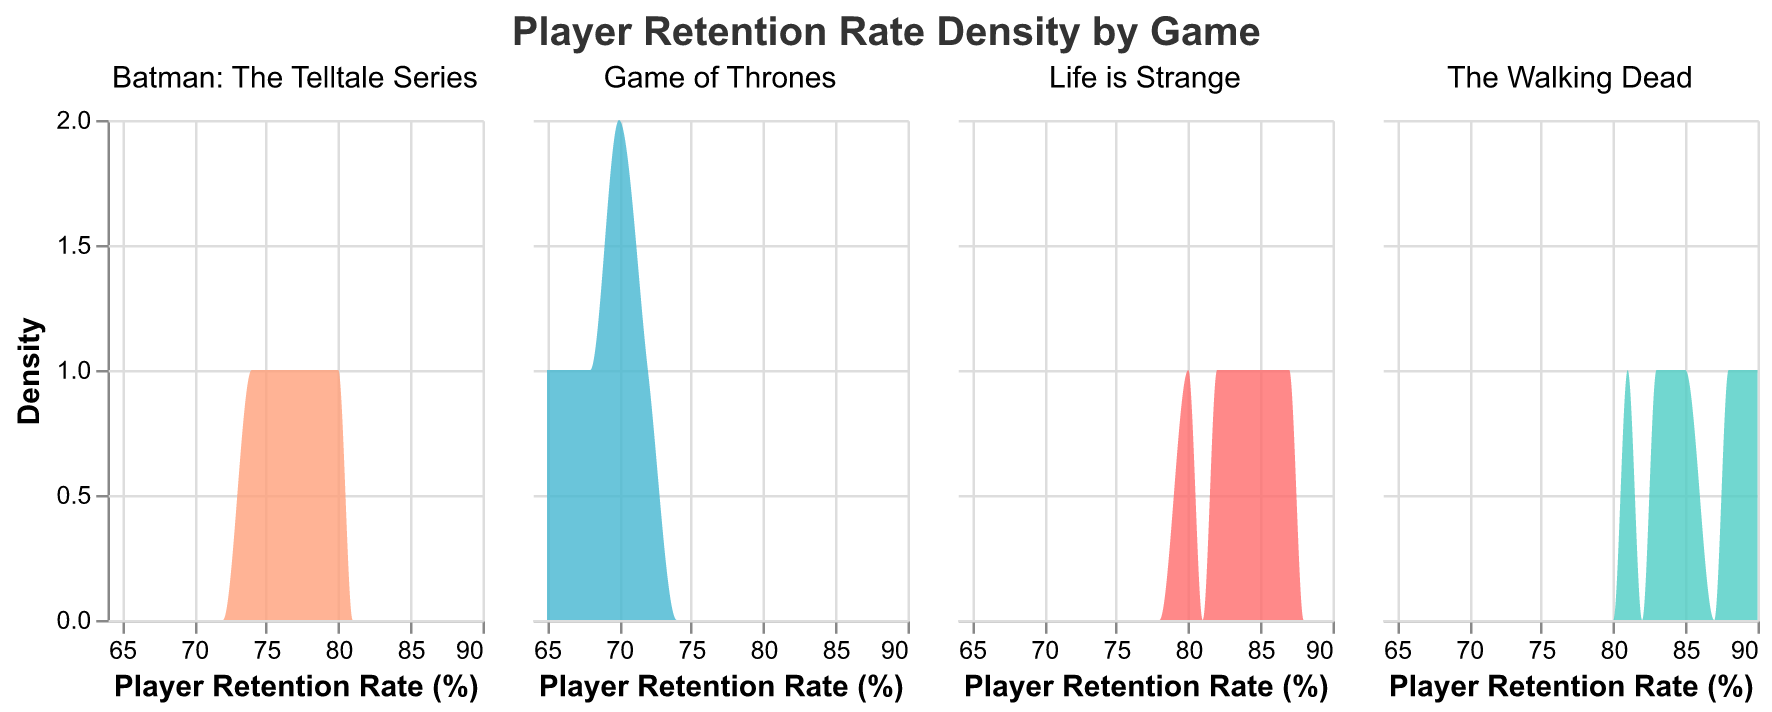What is the title of the figure? The title of the figure is typically displayed at the top of the plot. In this case, it is: "Player Retention Rate Density by Game"
Answer: Player Retention Rate Density by Game How is the x-axis labeled? The x-axis label is displayed at the bottom of the plot. Here, it is labeled: "Player Retention Rate (%)"
Answer: Player Retention Rate (%) Which game has the highest density peak? The game with the highest density peak can be identified by examining the peaks of each facet in the plot. The Walking Dead has the highest peak in the density plot.
Answer: The Walking Dead Which game has the widest spread of player retention rates? The game with the widest spread will have a wider range along the x-axis. Game of Thrones shows a wider spread of player retention rates compared to the others.
Answer: Game of Thrones Comparing "Life is Strange" and "Batman: The Telltale Series", which game has a higher player retention rate density at approximately 80%? By comparing the density areas around the 80% mark for both games in their respective plots, we can see that "Life is Strange" has a higher density at approximately 80%.
Answer: Life is Strange What is the color used to represent "The Walking Dead"? The color coding for "The Walking Dead" is seen in the plot and legend. It is represented by a teal-like color.
Answer: Teal What player retention rate does "Game of Thrones" have the highest density for? By examining the peak of the density plot for "Game of Thrones", the highest density occurs around the 70% player retention rate.
Answer: 70% Which game shows a consistent player retention rate across episodes, based on the density plot? A consistent player retention rate appears as a narrow, tall peak in the density plot. "The Walking Dead" seems to show a consistent player retention rate, particularly around high retention rates.
Answer: The Walking Dead Which game has the most variability in player retention rates? The game with the most variability will have a flatter, more spread-out density plot. Game of Thrones has the most variability in player retention rates.
Answer: Game of Thrones 